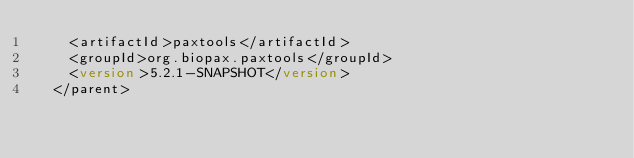Convert code to text. <code><loc_0><loc_0><loc_500><loc_500><_XML_>		<artifactId>paxtools</artifactId>
		<groupId>org.biopax.paxtools</groupId>
		<version>5.2.1-SNAPSHOT</version>
	</parent></code> 